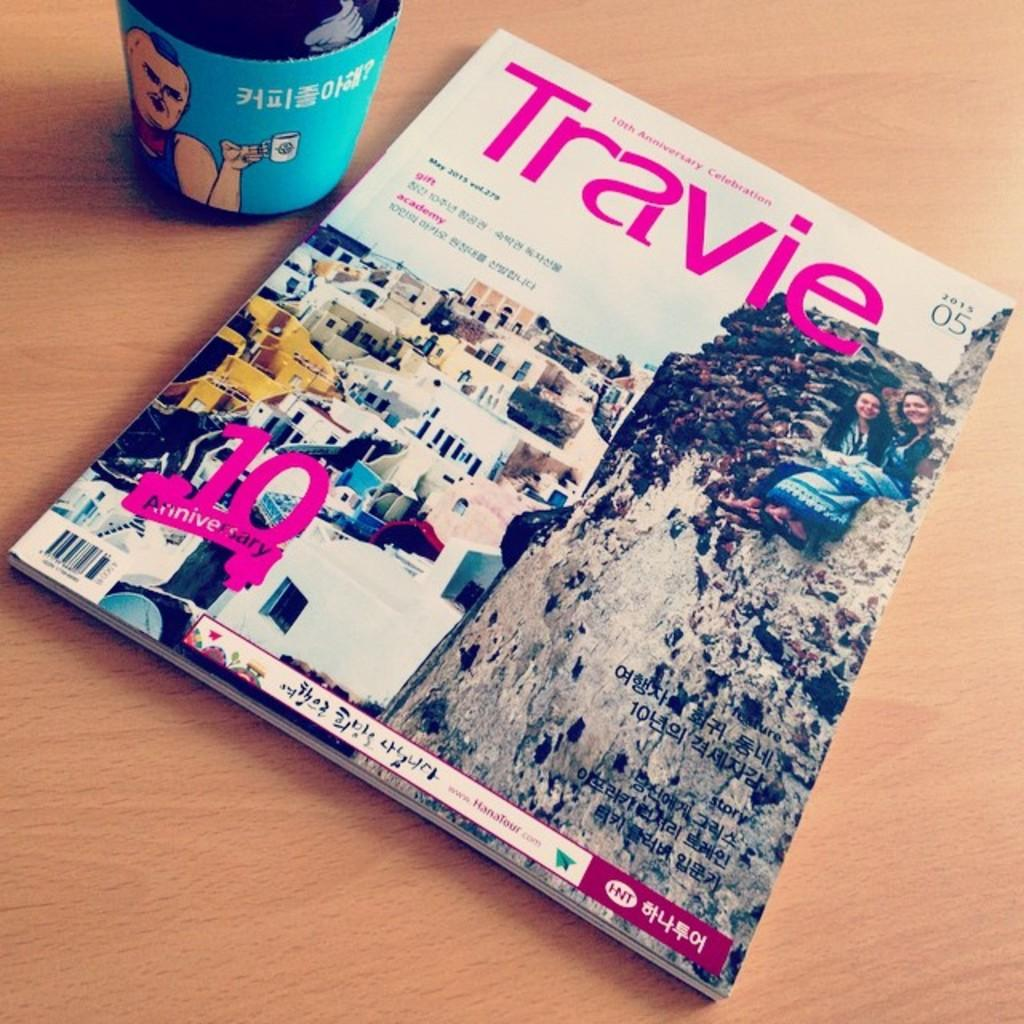<image>
Relay a brief, clear account of the picture shown. The cover of Travie magazine recognizes its tenth anniversary. 